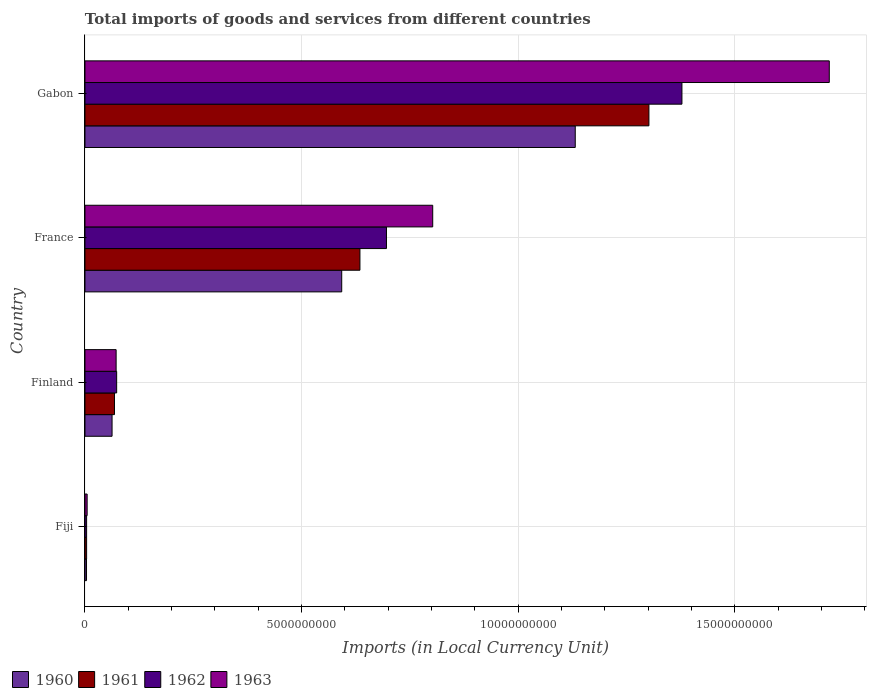How many different coloured bars are there?
Your answer should be very brief. 4. How many groups of bars are there?
Your answer should be compact. 4. Are the number of bars on each tick of the Y-axis equal?
Offer a terse response. Yes. What is the label of the 1st group of bars from the top?
Provide a short and direct response. Gabon. What is the Amount of goods and services imports in 1962 in Fiji?
Provide a succinct answer. 3.79e+07. Across all countries, what is the maximum Amount of goods and services imports in 1961?
Offer a very short reply. 1.30e+1. Across all countries, what is the minimum Amount of goods and services imports in 1960?
Give a very brief answer. 3.56e+07. In which country was the Amount of goods and services imports in 1963 maximum?
Make the answer very short. Gabon. In which country was the Amount of goods and services imports in 1962 minimum?
Provide a short and direct response. Fiji. What is the total Amount of goods and services imports in 1962 in the graph?
Your answer should be very brief. 2.15e+1. What is the difference between the Amount of goods and services imports in 1961 in Fiji and that in France?
Offer a terse response. -6.31e+09. What is the difference between the Amount of goods and services imports in 1963 in France and the Amount of goods and services imports in 1962 in Gabon?
Keep it short and to the point. -5.75e+09. What is the average Amount of goods and services imports in 1960 per country?
Give a very brief answer. 4.48e+09. What is the difference between the Amount of goods and services imports in 1960 and Amount of goods and services imports in 1961 in Finland?
Your answer should be very brief. -5.61e+07. What is the ratio of the Amount of goods and services imports in 1962 in Fiji to that in France?
Provide a succinct answer. 0.01. Is the Amount of goods and services imports in 1960 in Finland less than that in Gabon?
Ensure brevity in your answer.  Yes. What is the difference between the highest and the second highest Amount of goods and services imports in 1962?
Make the answer very short. 6.82e+09. What is the difference between the highest and the lowest Amount of goods and services imports in 1960?
Provide a succinct answer. 1.13e+1. Is the sum of the Amount of goods and services imports in 1961 in Fiji and France greater than the maximum Amount of goods and services imports in 1963 across all countries?
Your response must be concise. No. Is it the case that in every country, the sum of the Amount of goods and services imports in 1960 and Amount of goods and services imports in 1963 is greater than the Amount of goods and services imports in 1961?
Offer a very short reply. Yes. How many bars are there?
Give a very brief answer. 16. Are all the bars in the graph horizontal?
Provide a short and direct response. Yes. What is the difference between two consecutive major ticks on the X-axis?
Make the answer very short. 5.00e+09. Does the graph contain grids?
Offer a very short reply. Yes. How many legend labels are there?
Your answer should be compact. 4. What is the title of the graph?
Your response must be concise. Total imports of goods and services from different countries. Does "1972" appear as one of the legend labels in the graph?
Give a very brief answer. No. What is the label or title of the X-axis?
Ensure brevity in your answer.  Imports (in Local Currency Unit). What is the label or title of the Y-axis?
Your answer should be very brief. Country. What is the Imports (in Local Currency Unit) in 1960 in Fiji?
Offer a terse response. 3.56e+07. What is the Imports (in Local Currency Unit) in 1961 in Fiji?
Your response must be concise. 3.79e+07. What is the Imports (in Local Currency Unit) of 1962 in Fiji?
Your answer should be compact. 3.79e+07. What is the Imports (in Local Currency Unit) of 1963 in Fiji?
Keep it short and to the point. 5.00e+07. What is the Imports (in Local Currency Unit) in 1960 in Finland?
Your answer should be very brief. 6.25e+08. What is the Imports (in Local Currency Unit) in 1961 in Finland?
Your response must be concise. 6.81e+08. What is the Imports (in Local Currency Unit) in 1962 in Finland?
Provide a succinct answer. 7.32e+08. What is the Imports (in Local Currency Unit) of 1963 in Finland?
Give a very brief answer. 7.19e+08. What is the Imports (in Local Currency Unit) of 1960 in France?
Your answer should be compact. 5.93e+09. What is the Imports (in Local Currency Unit) in 1961 in France?
Your answer should be compact. 6.35e+09. What is the Imports (in Local Currency Unit) of 1962 in France?
Provide a succinct answer. 6.96e+09. What is the Imports (in Local Currency Unit) of 1963 in France?
Make the answer very short. 8.03e+09. What is the Imports (in Local Currency Unit) of 1960 in Gabon?
Offer a terse response. 1.13e+1. What is the Imports (in Local Currency Unit) of 1961 in Gabon?
Your response must be concise. 1.30e+1. What is the Imports (in Local Currency Unit) in 1962 in Gabon?
Make the answer very short. 1.38e+1. What is the Imports (in Local Currency Unit) of 1963 in Gabon?
Your response must be concise. 1.72e+1. Across all countries, what is the maximum Imports (in Local Currency Unit) of 1960?
Make the answer very short. 1.13e+1. Across all countries, what is the maximum Imports (in Local Currency Unit) of 1961?
Make the answer very short. 1.30e+1. Across all countries, what is the maximum Imports (in Local Currency Unit) in 1962?
Offer a terse response. 1.38e+1. Across all countries, what is the maximum Imports (in Local Currency Unit) in 1963?
Keep it short and to the point. 1.72e+1. Across all countries, what is the minimum Imports (in Local Currency Unit) in 1960?
Offer a very short reply. 3.56e+07. Across all countries, what is the minimum Imports (in Local Currency Unit) of 1961?
Provide a short and direct response. 3.79e+07. Across all countries, what is the minimum Imports (in Local Currency Unit) of 1962?
Your response must be concise. 3.79e+07. What is the total Imports (in Local Currency Unit) of 1960 in the graph?
Your answer should be compact. 1.79e+1. What is the total Imports (in Local Currency Unit) of 1961 in the graph?
Offer a very short reply. 2.01e+1. What is the total Imports (in Local Currency Unit) in 1962 in the graph?
Offer a very short reply. 2.15e+1. What is the total Imports (in Local Currency Unit) in 1963 in the graph?
Offer a very short reply. 2.60e+1. What is the difference between the Imports (in Local Currency Unit) of 1960 in Fiji and that in Finland?
Give a very brief answer. -5.90e+08. What is the difference between the Imports (in Local Currency Unit) in 1961 in Fiji and that in Finland?
Give a very brief answer. -6.44e+08. What is the difference between the Imports (in Local Currency Unit) of 1962 in Fiji and that in Finland?
Ensure brevity in your answer.  -6.94e+08. What is the difference between the Imports (in Local Currency Unit) of 1963 in Fiji and that in Finland?
Make the answer very short. -6.69e+08. What is the difference between the Imports (in Local Currency Unit) of 1960 in Fiji and that in France?
Your answer should be very brief. -5.89e+09. What is the difference between the Imports (in Local Currency Unit) in 1961 in Fiji and that in France?
Offer a very short reply. -6.31e+09. What is the difference between the Imports (in Local Currency Unit) of 1962 in Fiji and that in France?
Make the answer very short. -6.92e+09. What is the difference between the Imports (in Local Currency Unit) of 1963 in Fiji and that in France?
Offer a terse response. -7.98e+09. What is the difference between the Imports (in Local Currency Unit) in 1960 in Fiji and that in Gabon?
Offer a terse response. -1.13e+1. What is the difference between the Imports (in Local Currency Unit) of 1961 in Fiji and that in Gabon?
Provide a succinct answer. -1.30e+1. What is the difference between the Imports (in Local Currency Unit) of 1962 in Fiji and that in Gabon?
Make the answer very short. -1.37e+1. What is the difference between the Imports (in Local Currency Unit) of 1963 in Fiji and that in Gabon?
Your response must be concise. -1.71e+1. What is the difference between the Imports (in Local Currency Unit) of 1960 in Finland and that in France?
Your answer should be compact. -5.30e+09. What is the difference between the Imports (in Local Currency Unit) in 1961 in Finland and that in France?
Provide a short and direct response. -5.67e+09. What is the difference between the Imports (in Local Currency Unit) in 1962 in Finland and that in France?
Provide a succinct answer. -6.23e+09. What is the difference between the Imports (in Local Currency Unit) in 1963 in Finland and that in France?
Provide a succinct answer. -7.31e+09. What is the difference between the Imports (in Local Currency Unit) of 1960 in Finland and that in Gabon?
Give a very brief answer. -1.07e+1. What is the difference between the Imports (in Local Currency Unit) in 1961 in Finland and that in Gabon?
Your answer should be very brief. -1.23e+1. What is the difference between the Imports (in Local Currency Unit) of 1962 in Finland and that in Gabon?
Ensure brevity in your answer.  -1.30e+1. What is the difference between the Imports (in Local Currency Unit) in 1963 in Finland and that in Gabon?
Offer a terse response. -1.65e+1. What is the difference between the Imports (in Local Currency Unit) in 1960 in France and that in Gabon?
Make the answer very short. -5.39e+09. What is the difference between the Imports (in Local Currency Unit) in 1961 in France and that in Gabon?
Your answer should be compact. -6.67e+09. What is the difference between the Imports (in Local Currency Unit) in 1962 in France and that in Gabon?
Keep it short and to the point. -6.82e+09. What is the difference between the Imports (in Local Currency Unit) in 1963 in France and that in Gabon?
Ensure brevity in your answer.  -9.15e+09. What is the difference between the Imports (in Local Currency Unit) of 1960 in Fiji and the Imports (in Local Currency Unit) of 1961 in Finland?
Keep it short and to the point. -6.46e+08. What is the difference between the Imports (in Local Currency Unit) of 1960 in Fiji and the Imports (in Local Currency Unit) of 1962 in Finland?
Ensure brevity in your answer.  -6.96e+08. What is the difference between the Imports (in Local Currency Unit) in 1960 in Fiji and the Imports (in Local Currency Unit) in 1963 in Finland?
Your answer should be compact. -6.84e+08. What is the difference between the Imports (in Local Currency Unit) in 1961 in Fiji and the Imports (in Local Currency Unit) in 1962 in Finland?
Offer a very short reply. -6.94e+08. What is the difference between the Imports (in Local Currency Unit) in 1961 in Fiji and the Imports (in Local Currency Unit) in 1963 in Finland?
Your answer should be very brief. -6.81e+08. What is the difference between the Imports (in Local Currency Unit) of 1962 in Fiji and the Imports (in Local Currency Unit) of 1963 in Finland?
Provide a succinct answer. -6.81e+08. What is the difference between the Imports (in Local Currency Unit) of 1960 in Fiji and the Imports (in Local Currency Unit) of 1961 in France?
Ensure brevity in your answer.  -6.31e+09. What is the difference between the Imports (in Local Currency Unit) of 1960 in Fiji and the Imports (in Local Currency Unit) of 1962 in France?
Your answer should be very brief. -6.92e+09. What is the difference between the Imports (in Local Currency Unit) in 1960 in Fiji and the Imports (in Local Currency Unit) in 1963 in France?
Make the answer very short. -7.99e+09. What is the difference between the Imports (in Local Currency Unit) in 1961 in Fiji and the Imports (in Local Currency Unit) in 1962 in France?
Provide a short and direct response. -6.92e+09. What is the difference between the Imports (in Local Currency Unit) of 1961 in Fiji and the Imports (in Local Currency Unit) of 1963 in France?
Your response must be concise. -7.99e+09. What is the difference between the Imports (in Local Currency Unit) of 1962 in Fiji and the Imports (in Local Currency Unit) of 1963 in France?
Ensure brevity in your answer.  -7.99e+09. What is the difference between the Imports (in Local Currency Unit) in 1960 in Fiji and the Imports (in Local Currency Unit) in 1961 in Gabon?
Your response must be concise. -1.30e+1. What is the difference between the Imports (in Local Currency Unit) of 1960 in Fiji and the Imports (in Local Currency Unit) of 1962 in Gabon?
Make the answer very short. -1.37e+1. What is the difference between the Imports (in Local Currency Unit) in 1960 in Fiji and the Imports (in Local Currency Unit) in 1963 in Gabon?
Provide a succinct answer. -1.71e+1. What is the difference between the Imports (in Local Currency Unit) of 1961 in Fiji and the Imports (in Local Currency Unit) of 1962 in Gabon?
Offer a very short reply. -1.37e+1. What is the difference between the Imports (in Local Currency Unit) in 1961 in Fiji and the Imports (in Local Currency Unit) in 1963 in Gabon?
Ensure brevity in your answer.  -1.71e+1. What is the difference between the Imports (in Local Currency Unit) of 1962 in Fiji and the Imports (in Local Currency Unit) of 1963 in Gabon?
Your answer should be very brief. -1.71e+1. What is the difference between the Imports (in Local Currency Unit) of 1960 in Finland and the Imports (in Local Currency Unit) of 1961 in France?
Your response must be concise. -5.72e+09. What is the difference between the Imports (in Local Currency Unit) of 1960 in Finland and the Imports (in Local Currency Unit) of 1962 in France?
Give a very brief answer. -6.33e+09. What is the difference between the Imports (in Local Currency Unit) of 1960 in Finland and the Imports (in Local Currency Unit) of 1963 in France?
Your answer should be compact. -7.40e+09. What is the difference between the Imports (in Local Currency Unit) in 1961 in Finland and the Imports (in Local Currency Unit) in 1962 in France?
Ensure brevity in your answer.  -6.28e+09. What is the difference between the Imports (in Local Currency Unit) in 1961 in Finland and the Imports (in Local Currency Unit) in 1963 in France?
Offer a very short reply. -7.35e+09. What is the difference between the Imports (in Local Currency Unit) in 1962 in Finland and the Imports (in Local Currency Unit) in 1963 in France?
Make the answer very short. -7.30e+09. What is the difference between the Imports (in Local Currency Unit) of 1960 in Finland and the Imports (in Local Currency Unit) of 1961 in Gabon?
Provide a succinct answer. -1.24e+1. What is the difference between the Imports (in Local Currency Unit) of 1960 in Finland and the Imports (in Local Currency Unit) of 1962 in Gabon?
Offer a terse response. -1.32e+1. What is the difference between the Imports (in Local Currency Unit) in 1960 in Finland and the Imports (in Local Currency Unit) in 1963 in Gabon?
Offer a very short reply. -1.66e+1. What is the difference between the Imports (in Local Currency Unit) in 1961 in Finland and the Imports (in Local Currency Unit) in 1962 in Gabon?
Your answer should be very brief. -1.31e+1. What is the difference between the Imports (in Local Currency Unit) of 1961 in Finland and the Imports (in Local Currency Unit) of 1963 in Gabon?
Your response must be concise. -1.65e+1. What is the difference between the Imports (in Local Currency Unit) of 1962 in Finland and the Imports (in Local Currency Unit) of 1963 in Gabon?
Your response must be concise. -1.65e+1. What is the difference between the Imports (in Local Currency Unit) in 1960 in France and the Imports (in Local Currency Unit) in 1961 in Gabon?
Provide a short and direct response. -7.09e+09. What is the difference between the Imports (in Local Currency Unit) of 1960 in France and the Imports (in Local Currency Unit) of 1962 in Gabon?
Your answer should be compact. -7.85e+09. What is the difference between the Imports (in Local Currency Unit) in 1960 in France and the Imports (in Local Currency Unit) in 1963 in Gabon?
Your answer should be very brief. -1.13e+1. What is the difference between the Imports (in Local Currency Unit) in 1961 in France and the Imports (in Local Currency Unit) in 1962 in Gabon?
Give a very brief answer. -7.43e+09. What is the difference between the Imports (in Local Currency Unit) of 1961 in France and the Imports (in Local Currency Unit) of 1963 in Gabon?
Your response must be concise. -1.08e+1. What is the difference between the Imports (in Local Currency Unit) of 1962 in France and the Imports (in Local Currency Unit) of 1963 in Gabon?
Offer a very short reply. -1.02e+1. What is the average Imports (in Local Currency Unit) in 1960 per country?
Offer a very short reply. 4.48e+09. What is the average Imports (in Local Currency Unit) in 1961 per country?
Provide a succinct answer. 5.02e+09. What is the average Imports (in Local Currency Unit) of 1962 per country?
Keep it short and to the point. 5.38e+09. What is the average Imports (in Local Currency Unit) of 1963 per country?
Your answer should be compact. 6.49e+09. What is the difference between the Imports (in Local Currency Unit) in 1960 and Imports (in Local Currency Unit) in 1961 in Fiji?
Provide a succinct answer. -2.30e+06. What is the difference between the Imports (in Local Currency Unit) of 1960 and Imports (in Local Currency Unit) of 1962 in Fiji?
Keep it short and to the point. -2.30e+06. What is the difference between the Imports (in Local Currency Unit) of 1960 and Imports (in Local Currency Unit) of 1963 in Fiji?
Keep it short and to the point. -1.44e+07. What is the difference between the Imports (in Local Currency Unit) in 1961 and Imports (in Local Currency Unit) in 1962 in Fiji?
Your response must be concise. 0. What is the difference between the Imports (in Local Currency Unit) of 1961 and Imports (in Local Currency Unit) of 1963 in Fiji?
Offer a terse response. -1.21e+07. What is the difference between the Imports (in Local Currency Unit) in 1962 and Imports (in Local Currency Unit) in 1963 in Fiji?
Keep it short and to the point. -1.21e+07. What is the difference between the Imports (in Local Currency Unit) in 1960 and Imports (in Local Currency Unit) in 1961 in Finland?
Your response must be concise. -5.61e+07. What is the difference between the Imports (in Local Currency Unit) of 1960 and Imports (in Local Currency Unit) of 1962 in Finland?
Offer a terse response. -1.06e+08. What is the difference between the Imports (in Local Currency Unit) in 1960 and Imports (in Local Currency Unit) in 1963 in Finland?
Offer a very short reply. -9.39e+07. What is the difference between the Imports (in Local Currency Unit) of 1961 and Imports (in Local Currency Unit) of 1962 in Finland?
Keep it short and to the point. -5.01e+07. What is the difference between the Imports (in Local Currency Unit) of 1961 and Imports (in Local Currency Unit) of 1963 in Finland?
Offer a very short reply. -3.78e+07. What is the difference between the Imports (in Local Currency Unit) in 1962 and Imports (in Local Currency Unit) in 1963 in Finland?
Your answer should be compact. 1.23e+07. What is the difference between the Imports (in Local Currency Unit) of 1960 and Imports (in Local Currency Unit) of 1961 in France?
Make the answer very short. -4.20e+08. What is the difference between the Imports (in Local Currency Unit) of 1960 and Imports (in Local Currency Unit) of 1962 in France?
Ensure brevity in your answer.  -1.03e+09. What is the difference between the Imports (in Local Currency Unit) of 1960 and Imports (in Local Currency Unit) of 1963 in France?
Provide a succinct answer. -2.10e+09. What is the difference between the Imports (in Local Currency Unit) in 1961 and Imports (in Local Currency Unit) in 1962 in France?
Offer a very short reply. -6.12e+08. What is the difference between the Imports (in Local Currency Unit) of 1961 and Imports (in Local Currency Unit) of 1963 in France?
Provide a succinct answer. -1.68e+09. What is the difference between the Imports (in Local Currency Unit) in 1962 and Imports (in Local Currency Unit) in 1963 in France?
Give a very brief answer. -1.07e+09. What is the difference between the Imports (in Local Currency Unit) in 1960 and Imports (in Local Currency Unit) in 1961 in Gabon?
Your answer should be compact. -1.70e+09. What is the difference between the Imports (in Local Currency Unit) of 1960 and Imports (in Local Currency Unit) of 1962 in Gabon?
Offer a terse response. -2.46e+09. What is the difference between the Imports (in Local Currency Unit) of 1960 and Imports (in Local Currency Unit) of 1963 in Gabon?
Your answer should be very brief. -5.86e+09. What is the difference between the Imports (in Local Currency Unit) in 1961 and Imports (in Local Currency Unit) in 1962 in Gabon?
Offer a terse response. -7.62e+08. What is the difference between the Imports (in Local Currency Unit) in 1961 and Imports (in Local Currency Unit) in 1963 in Gabon?
Your response must be concise. -4.16e+09. What is the difference between the Imports (in Local Currency Unit) of 1962 and Imports (in Local Currency Unit) of 1963 in Gabon?
Keep it short and to the point. -3.40e+09. What is the ratio of the Imports (in Local Currency Unit) of 1960 in Fiji to that in Finland?
Your answer should be compact. 0.06. What is the ratio of the Imports (in Local Currency Unit) of 1961 in Fiji to that in Finland?
Provide a short and direct response. 0.06. What is the ratio of the Imports (in Local Currency Unit) of 1962 in Fiji to that in Finland?
Your answer should be compact. 0.05. What is the ratio of the Imports (in Local Currency Unit) in 1963 in Fiji to that in Finland?
Ensure brevity in your answer.  0.07. What is the ratio of the Imports (in Local Currency Unit) of 1960 in Fiji to that in France?
Your response must be concise. 0.01. What is the ratio of the Imports (in Local Currency Unit) in 1961 in Fiji to that in France?
Make the answer very short. 0.01. What is the ratio of the Imports (in Local Currency Unit) of 1962 in Fiji to that in France?
Ensure brevity in your answer.  0.01. What is the ratio of the Imports (in Local Currency Unit) of 1963 in Fiji to that in France?
Offer a terse response. 0.01. What is the ratio of the Imports (in Local Currency Unit) of 1960 in Fiji to that in Gabon?
Your answer should be very brief. 0. What is the ratio of the Imports (in Local Currency Unit) of 1961 in Fiji to that in Gabon?
Provide a succinct answer. 0. What is the ratio of the Imports (in Local Currency Unit) in 1962 in Fiji to that in Gabon?
Provide a succinct answer. 0. What is the ratio of the Imports (in Local Currency Unit) in 1963 in Fiji to that in Gabon?
Ensure brevity in your answer.  0. What is the ratio of the Imports (in Local Currency Unit) in 1960 in Finland to that in France?
Your answer should be very brief. 0.11. What is the ratio of the Imports (in Local Currency Unit) of 1961 in Finland to that in France?
Keep it short and to the point. 0.11. What is the ratio of the Imports (in Local Currency Unit) in 1962 in Finland to that in France?
Your answer should be compact. 0.11. What is the ratio of the Imports (in Local Currency Unit) of 1963 in Finland to that in France?
Your answer should be very brief. 0.09. What is the ratio of the Imports (in Local Currency Unit) of 1960 in Finland to that in Gabon?
Provide a short and direct response. 0.06. What is the ratio of the Imports (in Local Currency Unit) of 1961 in Finland to that in Gabon?
Provide a succinct answer. 0.05. What is the ratio of the Imports (in Local Currency Unit) in 1962 in Finland to that in Gabon?
Ensure brevity in your answer.  0.05. What is the ratio of the Imports (in Local Currency Unit) of 1963 in Finland to that in Gabon?
Give a very brief answer. 0.04. What is the ratio of the Imports (in Local Currency Unit) of 1960 in France to that in Gabon?
Provide a short and direct response. 0.52. What is the ratio of the Imports (in Local Currency Unit) of 1961 in France to that in Gabon?
Provide a short and direct response. 0.49. What is the ratio of the Imports (in Local Currency Unit) in 1962 in France to that in Gabon?
Your response must be concise. 0.51. What is the ratio of the Imports (in Local Currency Unit) of 1963 in France to that in Gabon?
Your response must be concise. 0.47. What is the difference between the highest and the second highest Imports (in Local Currency Unit) of 1960?
Offer a very short reply. 5.39e+09. What is the difference between the highest and the second highest Imports (in Local Currency Unit) of 1961?
Give a very brief answer. 6.67e+09. What is the difference between the highest and the second highest Imports (in Local Currency Unit) of 1962?
Your answer should be very brief. 6.82e+09. What is the difference between the highest and the second highest Imports (in Local Currency Unit) in 1963?
Ensure brevity in your answer.  9.15e+09. What is the difference between the highest and the lowest Imports (in Local Currency Unit) of 1960?
Your answer should be compact. 1.13e+1. What is the difference between the highest and the lowest Imports (in Local Currency Unit) in 1961?
Your response must be concise. 1.30e+1. What is the difference between the highest and the lowest Imports (in Local Currency Unit) of 1962?
Provide a short and direct response. 1.37e+1. What is the difference between the highest and the lowest Imports (in Local Currency Unit) in 1963?
Make the answer very short. 1.71e+1. 